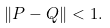<formula> <loc_0><loc_0><loc_500><loc_500>\| P - Q \| < 1 .</formula> 